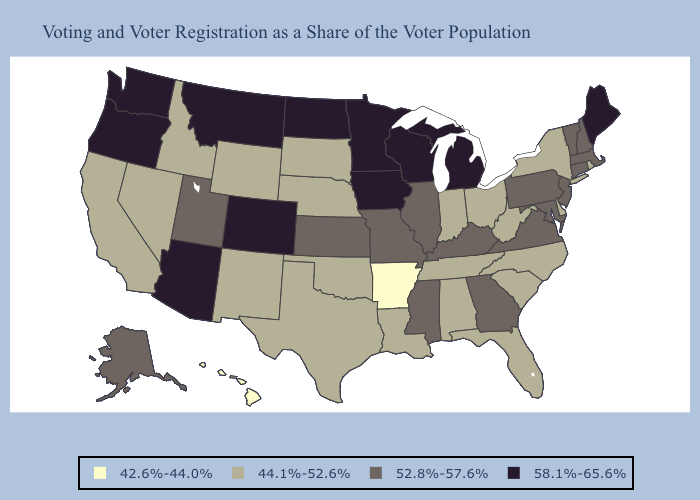Which states hav the highest value in the South?
Give a very brief answer. Georgia, Kentucky, Maryland, Mississippi, Virginia. What is the highest value in the Northeast ?
Short answer required. 58.1%-65.6%. Does Hawaii have the lowest value in the USA?
Keep it brief. Yes. Does Texas have the same value as Illinois?
Write a very short answer. No. Name the states that have a value in the range 42.6%-44.0%?
Keep it brief. Arkansas, Hawaii. What is the lowest value in the USA?
Keep it brief. 42.6%-44.0%. What is the lowest value in the USA?
Concise answer only. 42.6%-44.0%. Among the states that border California , does Nevada have the highest value?
Write a very short answer. No. Among the states that border Iowa , does Wisconsin have the highest value?
Concise answer only. Yes. What is the value of Maryland?
Concise answer only. 52.8%-57.6%. Does Rhode Island have the same value as Illinois?
Be succinct. No. What is the value of Washington?
Write a very short answer. 58.1%-65.6%. What is the value of Kentucky?
Give a very brief answer. 52.8%-57.6%. What is the value of Pennsylvania?
Answer briefly. 52.8%-57.6%. Among the states that border New Mexico , which have the highest value?
Answer briefly. Arizona, Colorado. 